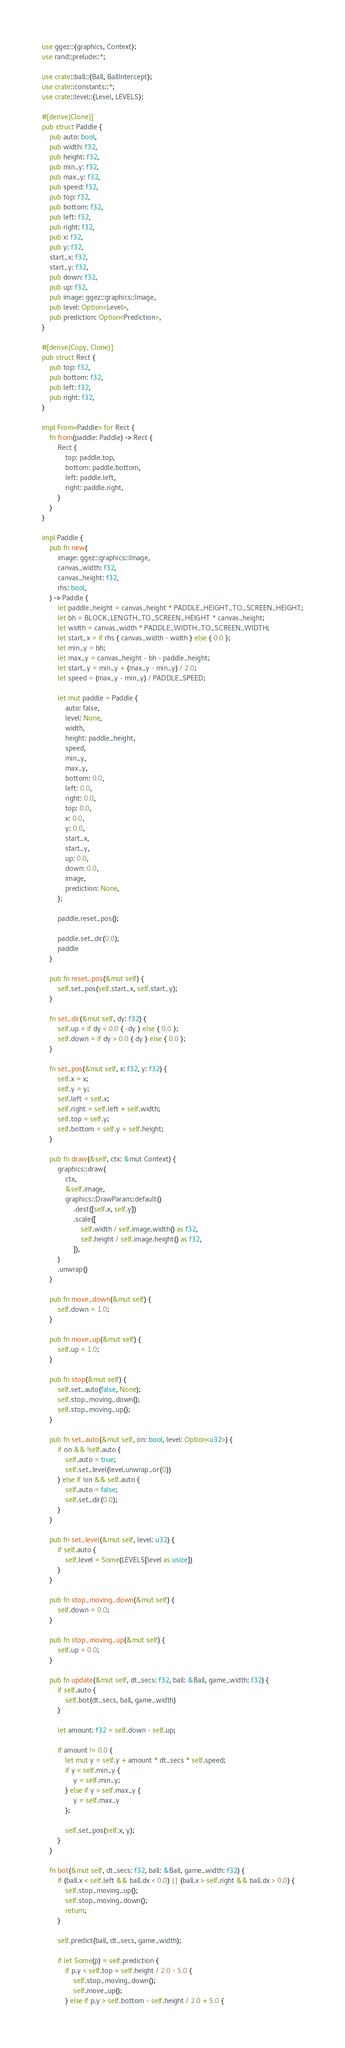<code> <loc_0><loc_0><loc_500><loc_500><_Rust_>use ggez::{graphics, Context};
use rand::prelude::*;

use crate::ball::{Ball, BallIntercept};
use crate::constants::*;
use crate::level::{Level, LEVELS};

#[derive(Clone)]
pub struct Paddle {
    pub auto: bool,
    pub width: f32,
    pub height: f32,
    pub min_y: f32,
    pub max_y: f32,
    pub speed: f32,
    pub top: f32,
    pub bottom: f32,
    pub left: f32,
    pub right: f32,
    pub x: f32,
    pub y: f32,
    start_x: f32,
    start_y: f32,
    pub down: f32,
    pub up: f32,
    pub image: ggez::graphics::Image,
    pub level: Option<Level>,
    pub prediction: Option<Prediction>,
}

#[derive(Copy, Clone)]
pub struct Rect {
    pub top: f32,
    pub bottom: f32,
    pub left: f32,
    pub right: f32,
}

impl From<Paddle> for Rect {
    fn from(paddle: Paddle) -> Rect {
        Rect {
            top: paddle.top,
            bottom: paddle.bottom,
            left: paddle.left,
            right: paddle.right,
        }
    }
}

impl Paddle {
    pub fn new(
        image: ggez::graphics::Image,
        canvas_width: f32,
        canvas_height: f32,
        rhs: bool,
    ) -> Paddle {
        let paddle_height = canvas_height * PADDLE_HEIGHT_TO_SCREEN_HEIGHT;
        let bh = BLOCK_LENGTH_TO_SCREEN_HEIGHT * canvas_height;
        let width = canvas_width * PADDLE_WIDTH_TO_SCREEN_WIDTH;
        let start_x = if rhs { canvas_width - width } else { 0.0 };
        let min_y = bh;
        let max_y = canvas_height - bh - paddle_height;
        let start_y = min_y + (max_y - min_y) / 2.0;
        let speed = (max_y - min_y) / PADDLE_SPEED;

        let mut paddle = Paddle {
            auto: false,
            level: None,
            width,
            height: paddle_height,
            speed,
            min_y,
            max_y,
            bottom: 0.0,
            left: 0.0,
            right: 0.0,
            top: 0.0,
            x: 0.0,
            y: 0.0,
            start_x,
            start_y,
            up: 0.0,
            down: 0.0,
            image,
            prediction: None,
        };

        paddle.reset_pos();

        paddle.set_dir(0.0);
        paddle
    }

    pub fn reset_pos(&mut self) {
        self.set_pos(self.start_x, self.start_y);
    }

    fn set_dir(&mut self, dy: f32) {
        self.up = if dy < 0.0 { -dy } else { 0.0 };
        self.down = if dy > 0.0 { dy } else { 0.0 };
    }

    fn set_pos(&mut self, x: f32, y: f32) {
        self.x = x;
        self.y = y;
        self.left = self.x;
        self.right = self.left + self.width;
        self.top = self.y;
        self.bottom = self.y + self.height;
    }

    pub fn draw(&self, ctx: &mut Context) {
        graphics::draw(
            ctx,
            &self.image,
            graphics::DrawParam::default()
                .dest([self.x, self.y])
                .scale([
                    self.width / self.image.width() as f32,
                    self.height / self.image.height() as f32,
                ]),
        )
        .unwrap()
    }

    pub fn move_down(&mut self) {
        self.down = 1.0;
    }

    pub fn move_up(&mut self) {
        self.up = 1.0;
    }

    pub fn stop(&mut self) {
        self.set_auto(false, None);
        self.stop_moving_down();
        self.stop_moving_up();
    }

    pub fn set_auto(&mut self, on: bool, level: Option<u32>) {
        if on && !self.auto {
            self.auto = true;
            self.set_level(level.unwrap_or(0))
        } else if !on && self.auto {
            self.auto = false;
            self.set_dir(0.0);
        }
    }

    pub fn set_level(&mut self, level: u32) {
        if self.auto {
            self.level = Some(LEVELS[level as usize])
        }
    }

    pub fn stop_moving_down(&mut self) {
        self.down = 0.0;
    }

    pub fn stop_moving_up(&mut self) {
        self.up = 0.0;
    }

    pub fn update(&mut self, dt_secs: f32, ball: &Ball, game_width: f32) {
        if self.auto {
            self.bot(dt_secs, ball, game_width)
        }

        let amount: f32 = self.down - self.up;

        if amount != 0.0 {
            let mut y = self.y + amount * dt_secs * self.speed;
            if y < self.min_y {
                y = self.min_y;
            } else if y > self.max_y {
                y = self.max_y
            };

            self.set_pos(self.x, y);
        }
    }

    fn bot(&mut self, dt_secs: f32, ball: &Ball, game_width: f32) {
        if (ball.x < self.left && ball.dx < 0.0) || (ball.x > self.right && ball.dx > 0.0) {
            self.stop_moving_up();
            self.stop_moving_down();
            return;
        }

        self.predict(ball, dt_secs, game_width);

        if let Some(p) = self.prediction {
            if p.y < self.top + self.height / 2.0 - 5.0 {
                self.stop_moving_down();
                self.move_up();
            } else if p.y > self.bottom - self.height / 2.0 + 5.0 {</code> 